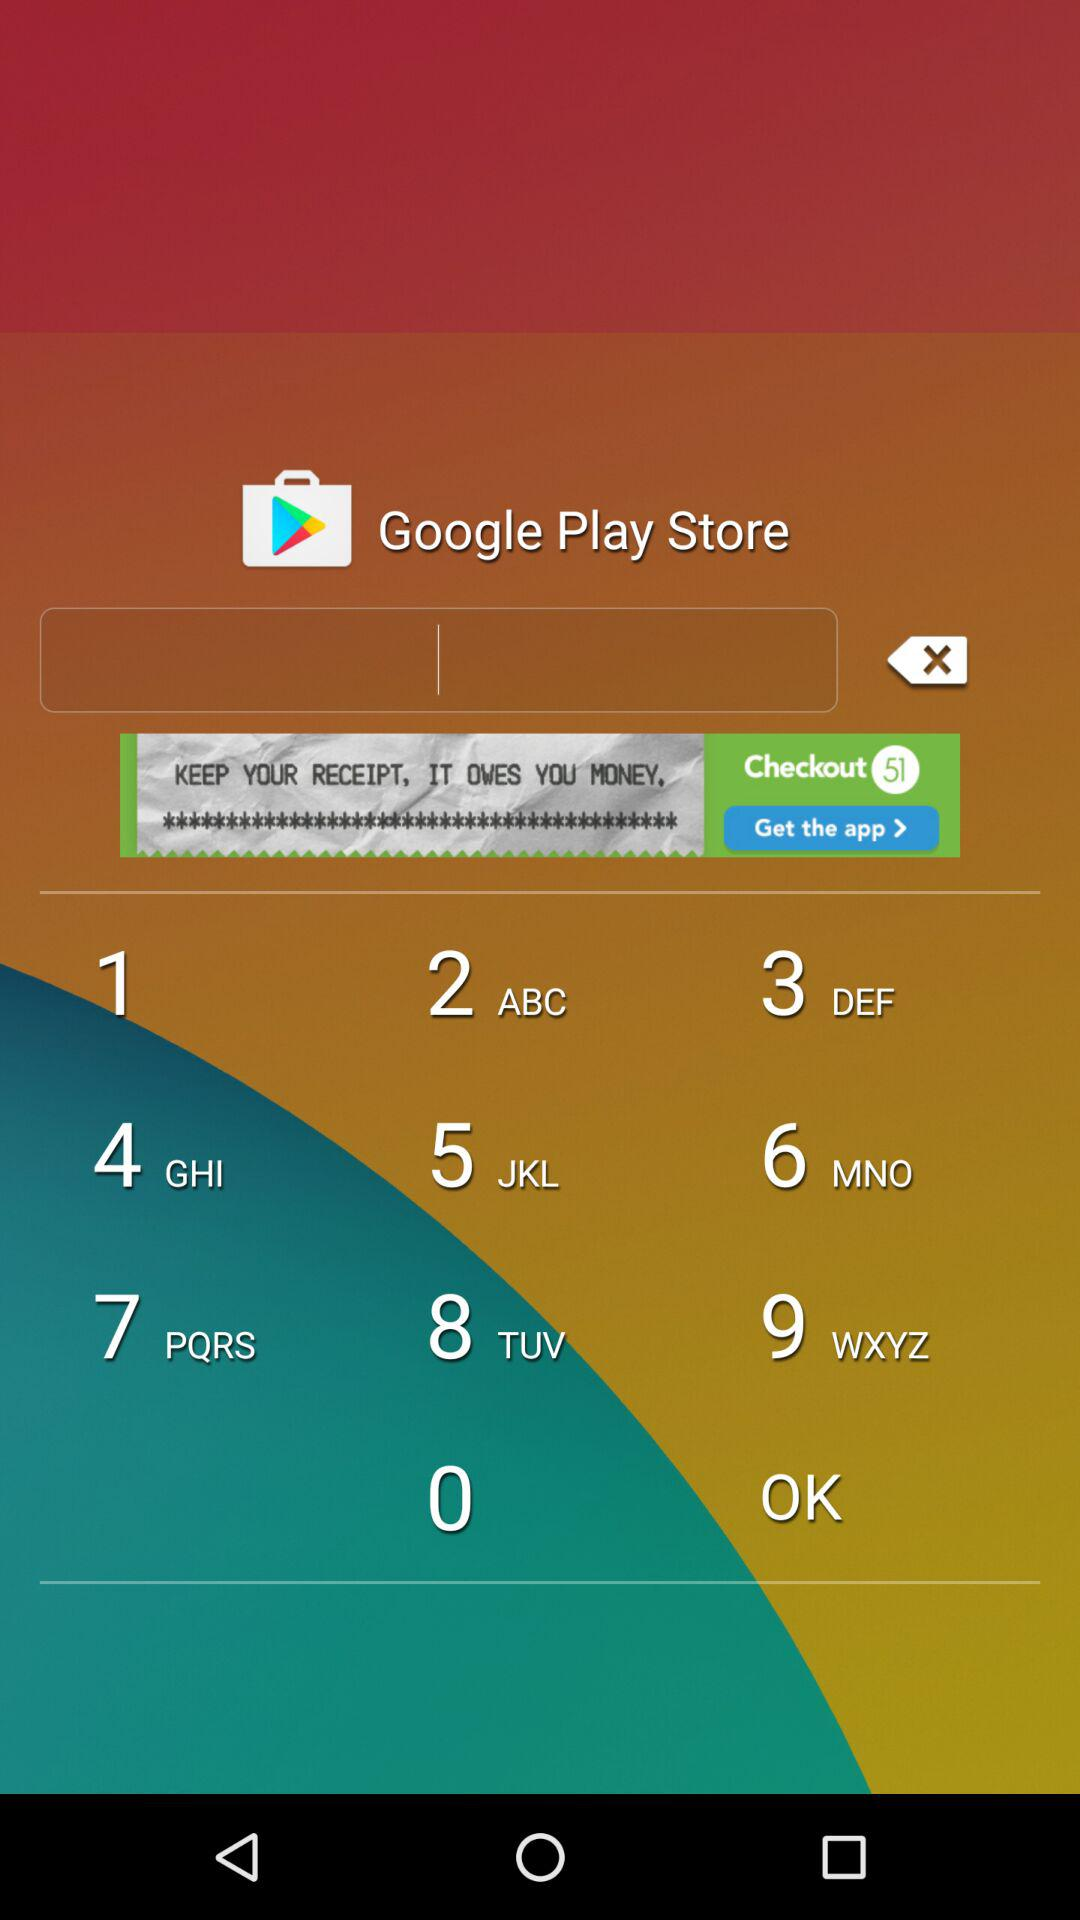What Gmail address is used? The used Gmail address is developer.app01@gmail.com. 